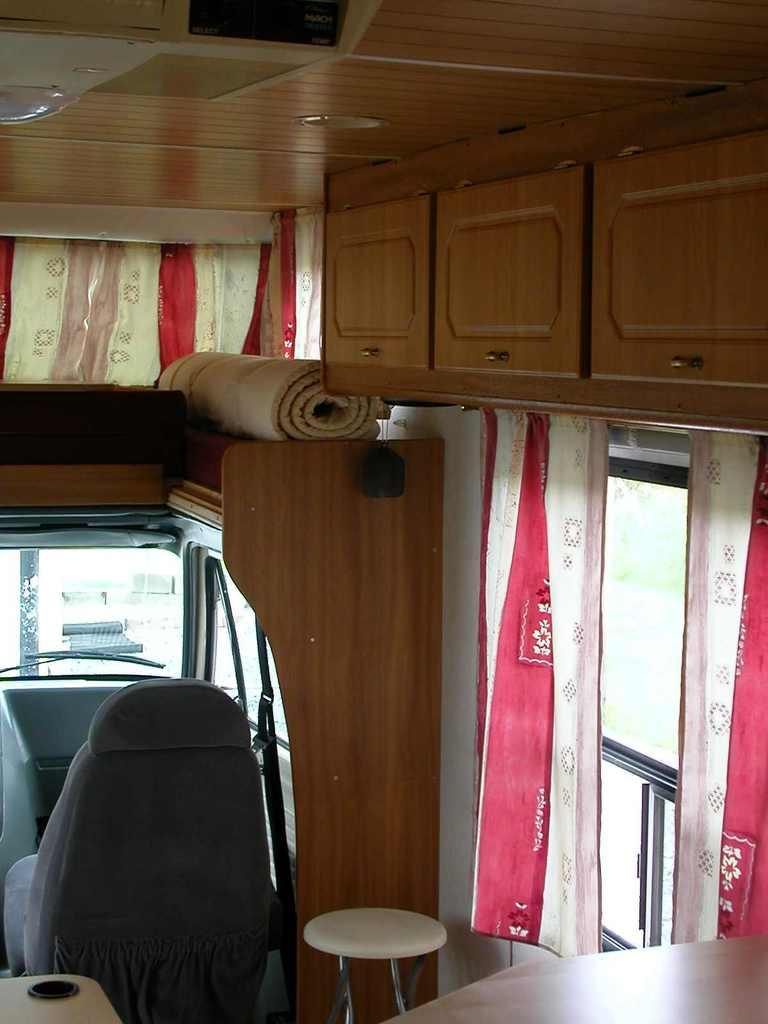What type of setting is depicted in the image? The image is of an indoor setting. What piece of furniture is present in the image? There is a table in the image. What type of seating is visible in the image? There is a chair in the image. What type of floor covering is present in the image? There is a mat in the image. What type of window treatment is present in the image? There is a curtain in the image. What type of furniture is present in the image? There is furniture in the image. How many windows are visible in the image? There are windows in the image. What type of card is being used to sound the alarm in the image? There is no card or alarm present in the image. What type of library is visible in the image? There is no library present in the image. 